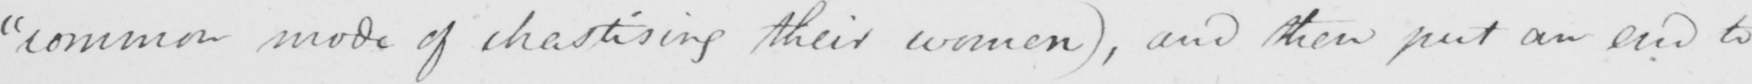Transcribe the text shown in this historical manuscript line. "common mode of chastising their women), and then put an end to 